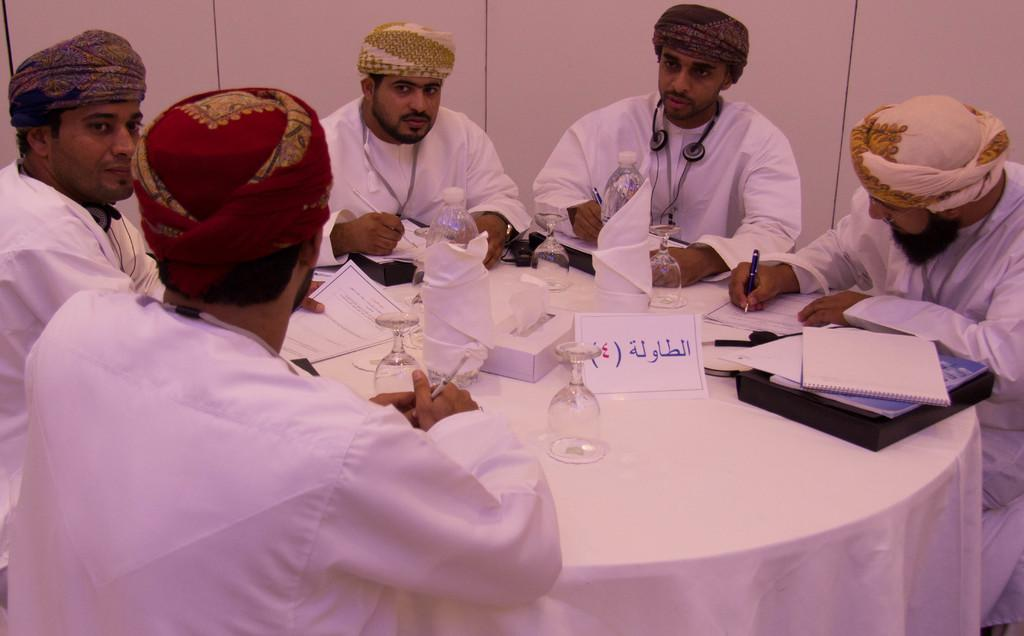What are the persons in the image wearing on their heads? The persons in the image are wearing hats. Where are the persons in the image located? They are in front of a table. What items can be seen on the table in the image? The table contains glasses, bottles, boxes, and books. What is visible at the top of the image? There is a wall at the top of the image. What type of noise can be heard coming from the pie in the image? There is no pie present in the image, so it is not possible to determine what, if any, noise might be heard. 